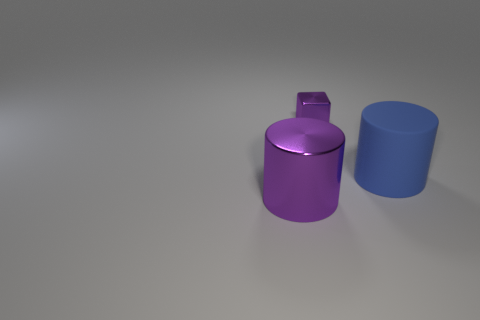Are there any other things that have the same shape as the small object?
Give a very brief answer. No. Is the number of cubes in front of the large matte cylinder less than the number of blue cylinders that are in front of the tiny block?
Keep it short and to the point. Yes. The big thing that is made of the same material as the tiny block is what color?
Provide a succinct answer. Purple. There is a purple cylinder on the left side of the small purple metallic cube; are there any purple metal things right of it?
Provide a short and direct response. Yes. What color is the metal thing that is the same size as the blue matte cylinder?
Your answer should be very brief. Purple. How many things are tiny red matte balls or big purple metal cylinders?
Make the answer very short. 1. There is a purple metallic object that is behind the cylinder that is behind the purple metallic object in front of the large blue matte object; what is its size?
Ensure brevity in your answer.  Small. How many cylinders are the same color as the tiny block?
Keep it short and to the point. 1. What number of big things are made of the same material as the block?
Your answer should be very brief. 1. How many things are big matte things or things in front of the small purple shiny thing?
Provide a succinct answer. 2. 